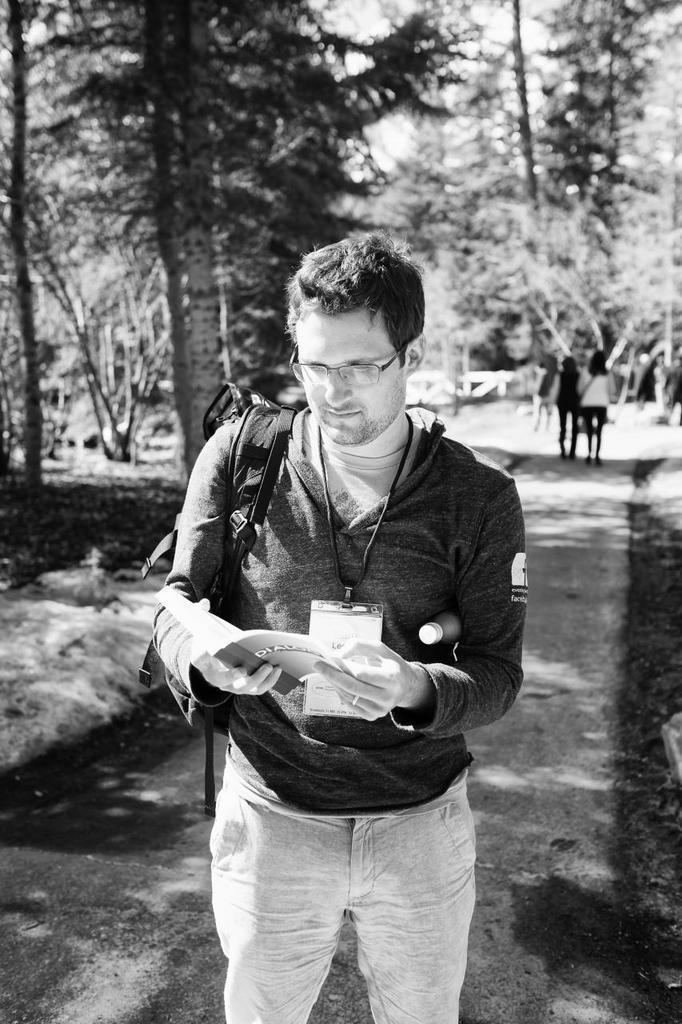Please provide a concise description of this image. In this image I can see a person holding a book and wearing a backpack standing on the ground and at the top I can see the trees and I can see two persons in the middle. 